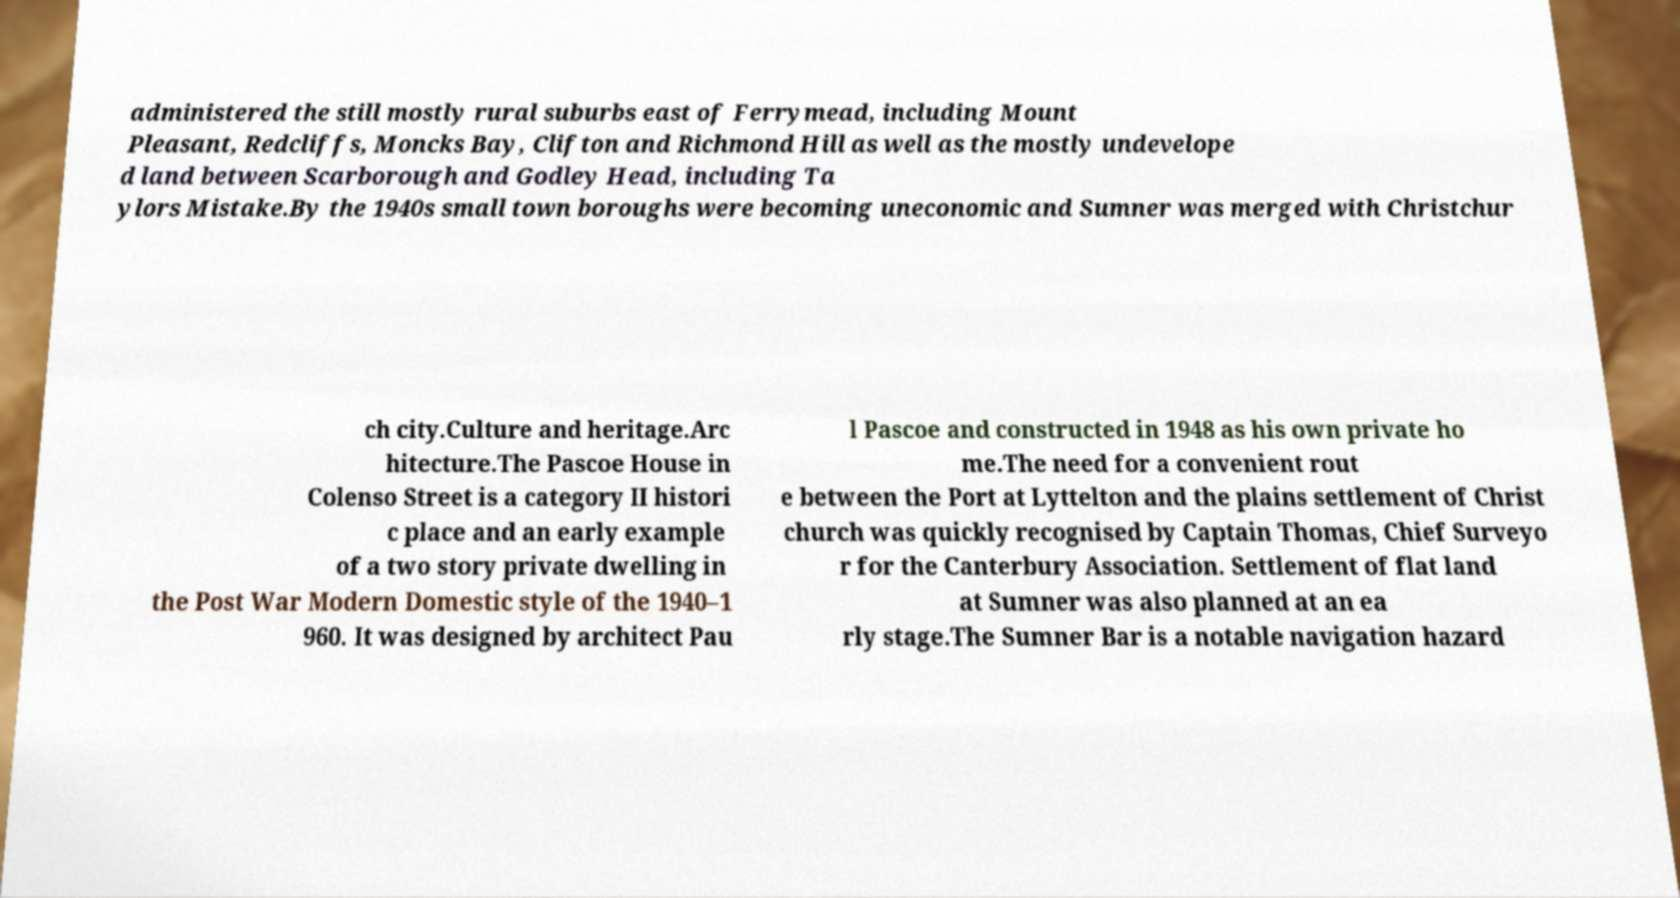There's text embedded in this image that I need extracted. Can you transcribe it verbatim? administered the still mostly rural suburbs east of Ferrymead, including Mount Pleasant, Redcliffs, Moncks Bay, Clifton and Richmond Hill as well as the mostly undevelope d land between Scarborough and Godley Head, including Ta ylors Mistake.By the 1940s small town boroughs were becoming uneconomic and Sumner was merged with Christchur ch city.Culture and heritage.Arc hitecture.The Pascoe House in Colenso Street is a category II histori c place and an early example of a two story private dwelling in the Post War Modern Domestic style of the 1940–1 960. It was designed by architect Pau l Pascoe and constructed in 1948 as his own private ho me.The need for a convenient rout e between the Port at Lyttelton and the plains settlement of Christ church was quickly recognised by Captain Thomas, Chief Surveyo r for the Canterbury Association. Settlement of flat land at Sumner was also planned at an ea rly stage.The Sumner Bar is a notable navigation hazard 